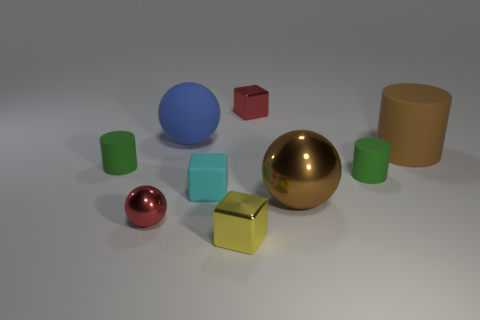Subtract all tiny metallic cubes. How many cubes are left? 1 Subtract all cyan cubes. How many cubes are left? 2 Add 1 matte cylinders. How many objects exist? 10 Subtract all cylinders. How many objects are left? 6 Add 7 small rubber things. How many small rubber things are left? 10 Add 6 small cyan cubes. How many small cyan cubes exist? 7 Subtract 0 purple spheres. How many objects are left? 9 Subtract 1 cylinders. How many cylinders are left? 2 Subtract all yellow spheres. Subtract all purple cylinders. How many spheres are left? 3 Subtract all brown balls. How many green cylinders are left? 2 